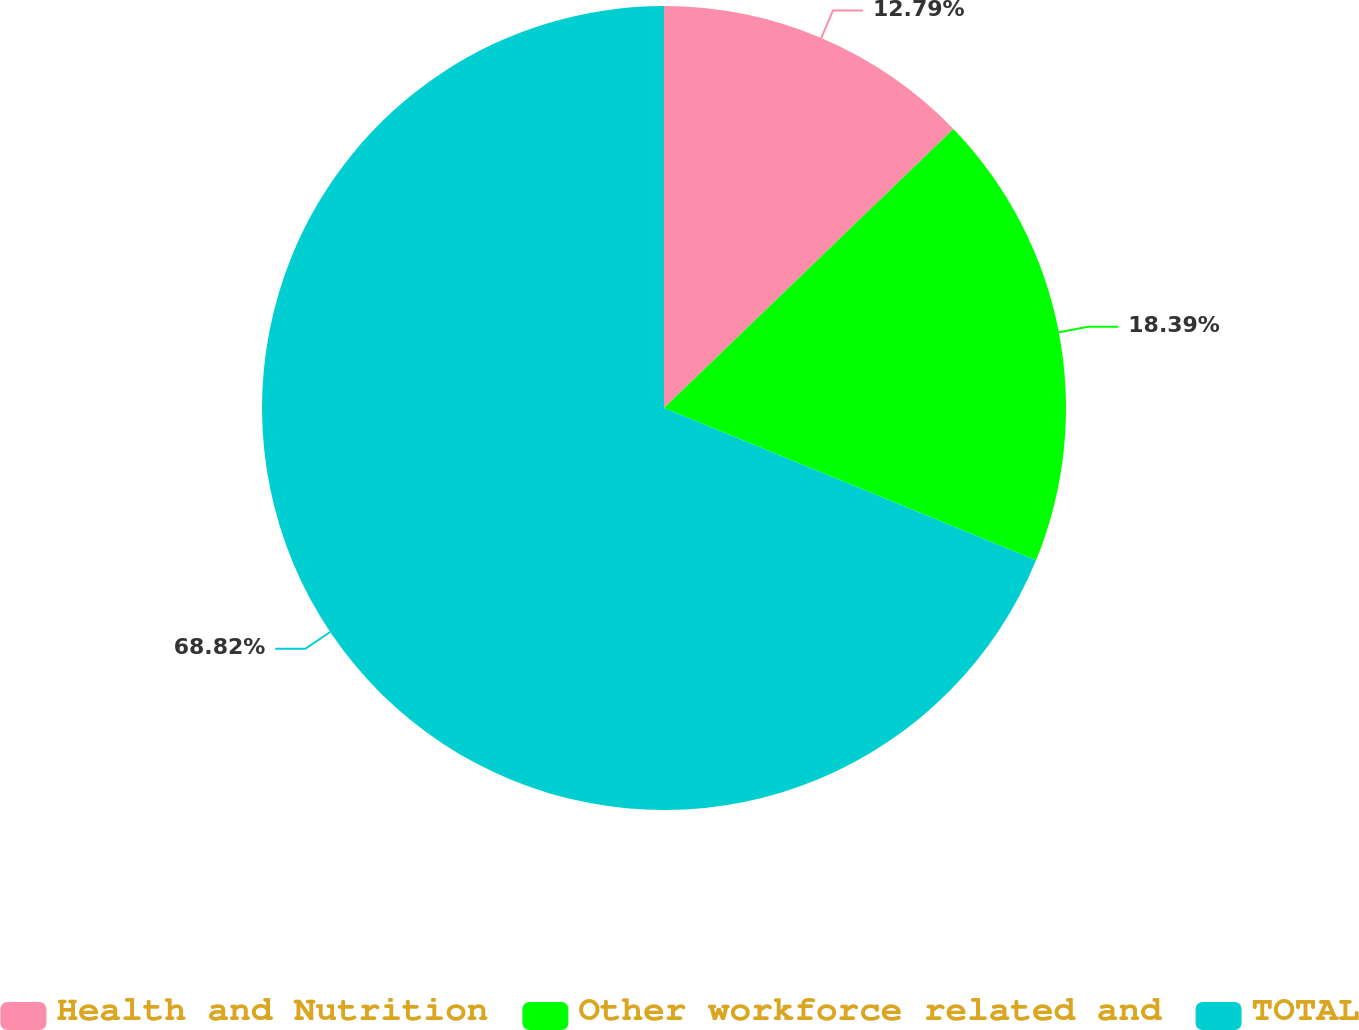Convert chart to OTSL. <chart><loc_0><loc_0><loc_500><loc_500><pie_chart><fcel>Health and Nutrition<fcel>Other workforce related and<fcel>TOTAL<nl><fcel>12.79%<fcel>18.39%<fcel>68.81%<nl></chart> 